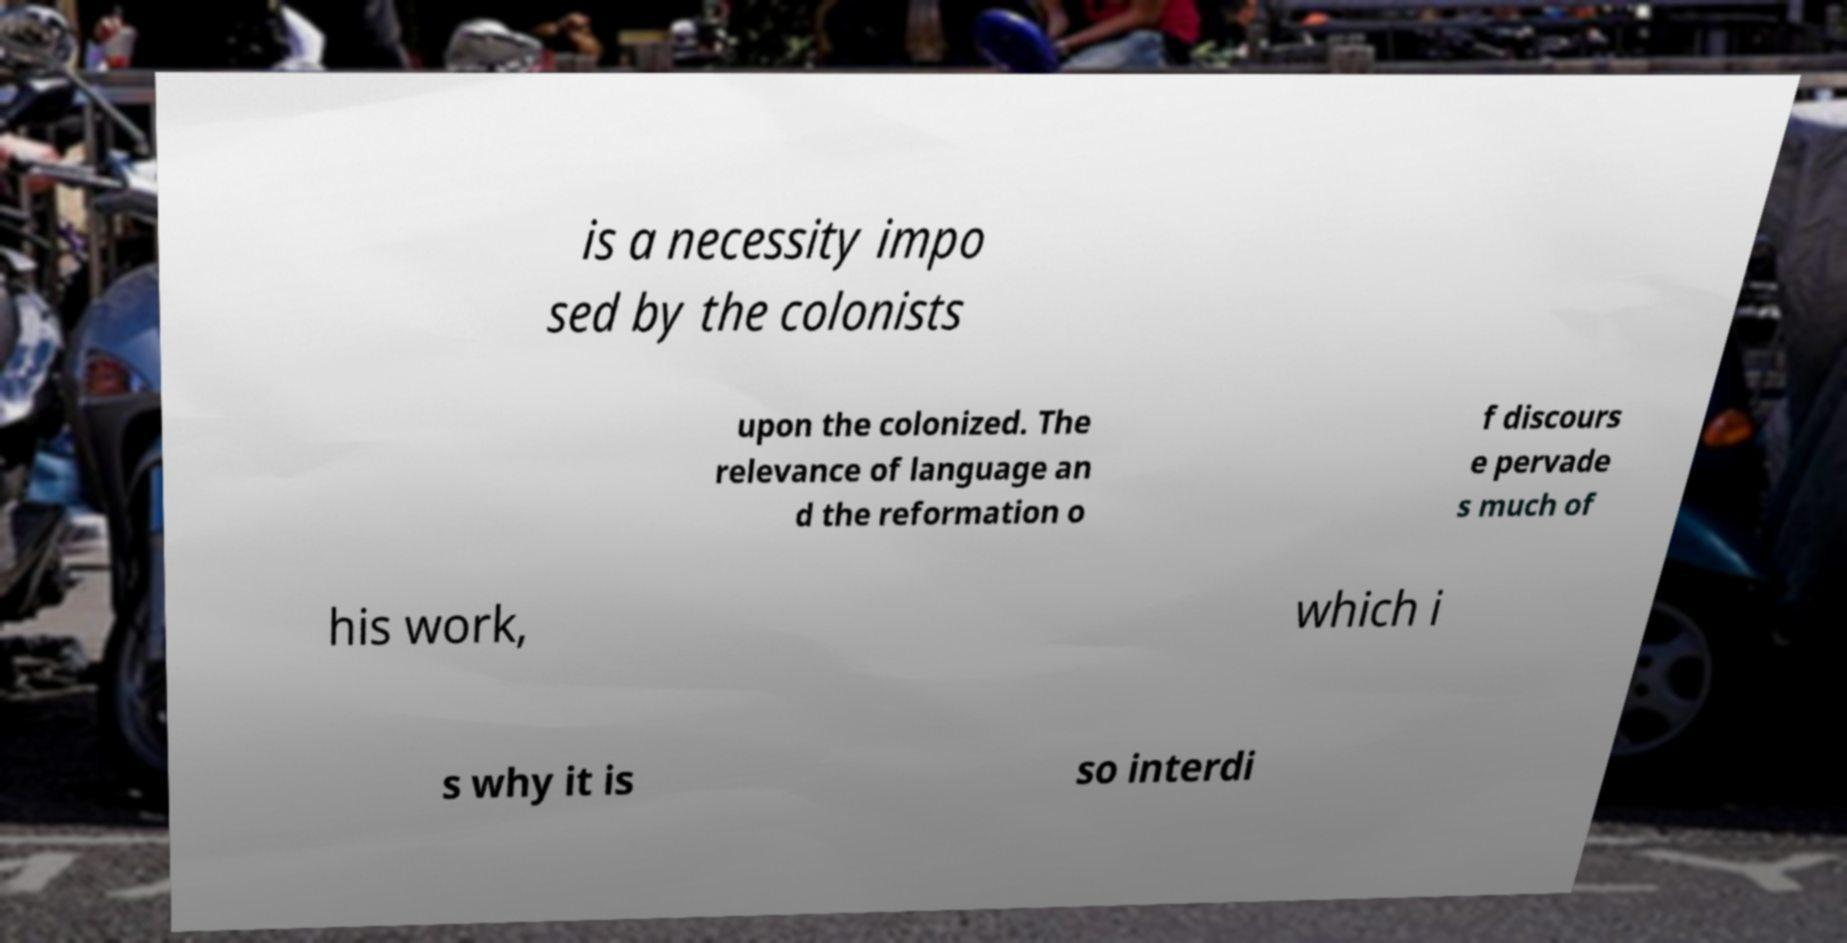What messages or text are displayed in this image? I need them in a readable, typed format. is a necessity impo sed by the colonists upon the colonized. The relevance of language an d the reformation o f discours e pervade s much of his work, which i s why it is so interdi 